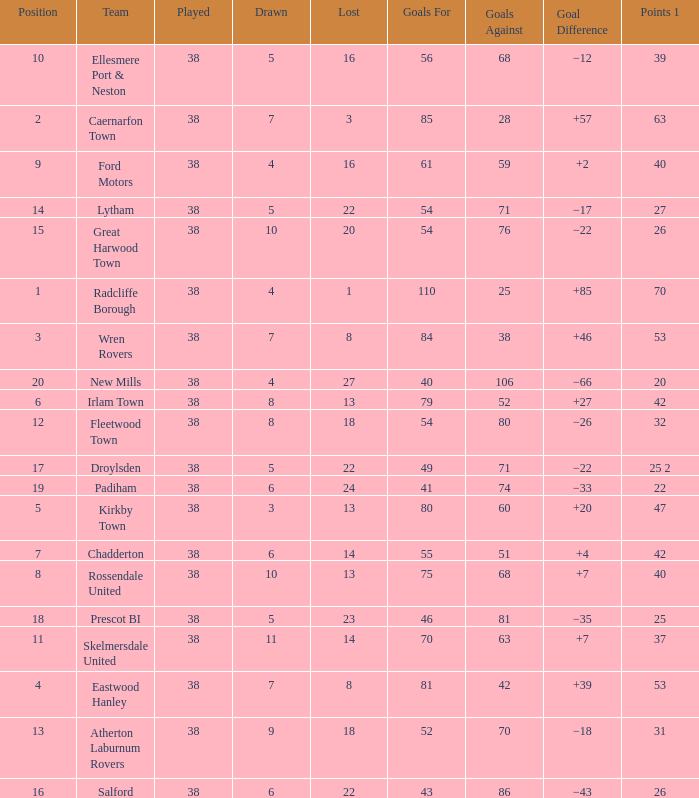How much Drawn has Goals Against of 81, and a Lost larger than 23? 0.0. 